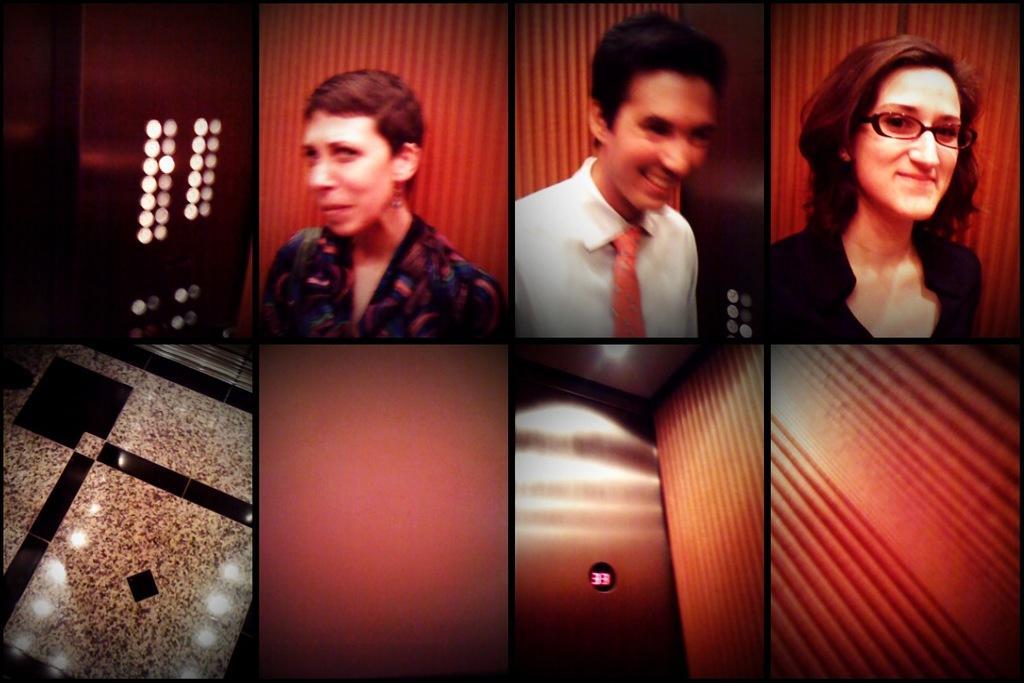In one or two sentences, can you explain what this image depicts? Here this picture is an collage image, in which we can see lift, buttons, floor, door and people standing in the lift and are smiling over there. 